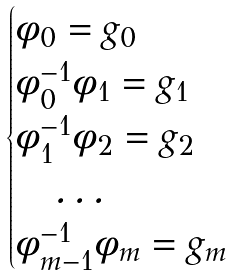Convert formula to latex. <formula><loc_0><loc_0><loc_500><loc_500>\begin{cases} \phi _ { 0 } = g _ { 0 } \\ \phi _ { 0 } ^ { - 1 } \phi _ { 1 } = g _ { 1 } \\ \phi _ { 1 } ^ { - 1 } \phi _ { 2 } = g _ { 2 } \\ \quad \dots \\ \phi _ { m - 1 } ^ { - 1 } \phi _ { m } = g _ { m } \\ \end{cases}</formula> 